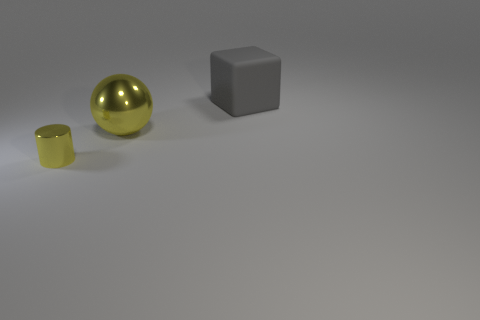Add 3 large cyan cylinders. How many objects exist? 6 Subtract all cubes. How many objects are left? 2 Add 2 yellow objects. How many yellow objects exist? 4 Subtract 1 yellow balls. How many objects are left? 2 Subtract all tiny yellow shiny cylinders. Subtract all small matte blocks. How many objects are left? 2 Add 3 big gray things. How many big gray things are left? 4 